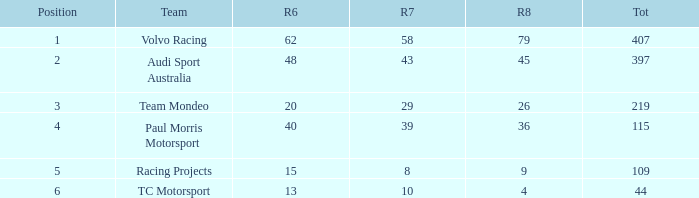What is the sum of total values for Rd 7 less than 8? None. 